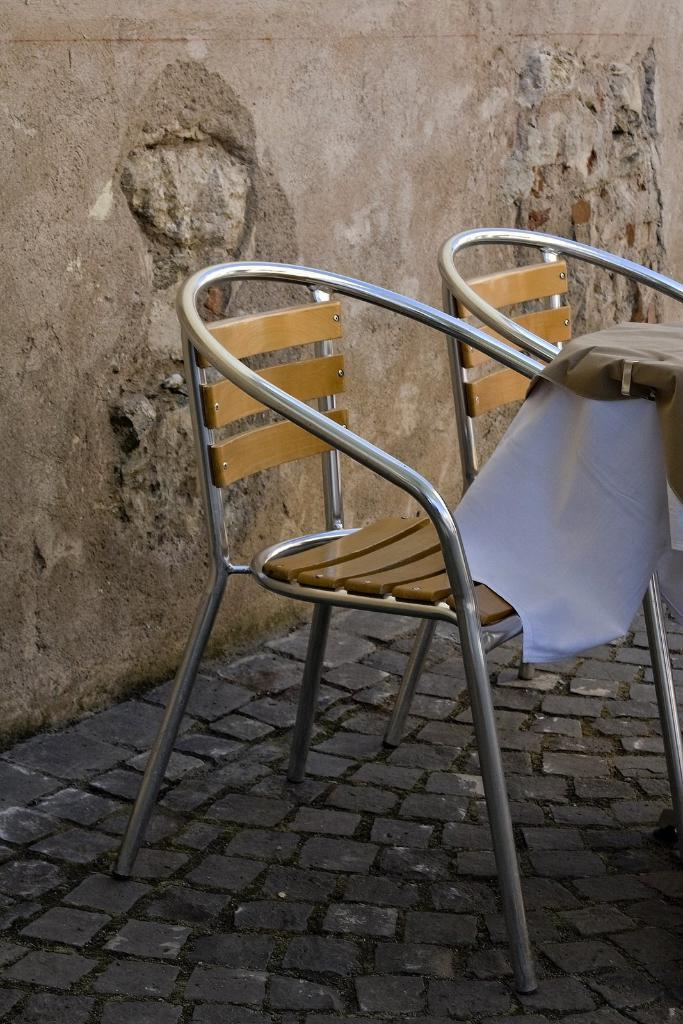How many chairs are in the image? There are two chairs in the image. What is on the table in the image? There is a cloth on a table in the image. What can be seen on the wall in the image? There is a wall visible in the image. What is the name of the person who is distributing skates in the image? There is no person distributing skates in the image; the image only features two chairs, a cloth on a table, and a wall. 